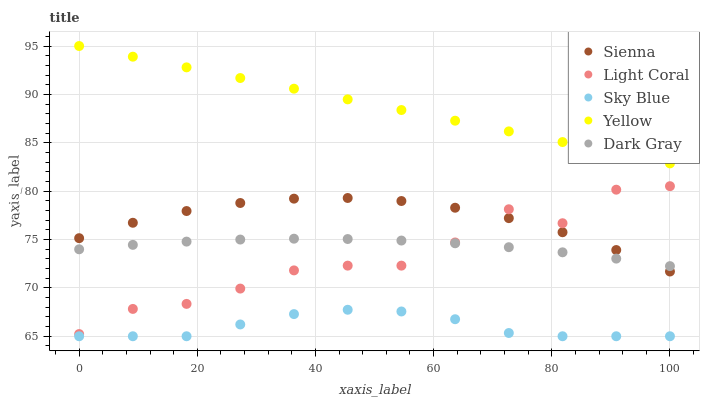Does Sky Blue have the minimum area under the curve?
Answer yes or no. Yes. Does Yellow have the maximum area under the curve?
Answer yes or no. Yes. Does Light Coral have the minimum area under the curve?
Answer yes or no. No. Does Light Coral have the maximum area under the curve?
Answer yes or no. No. Is Yellow the smoothest?
Answer yes or no. Yes. Is Light Coral the roughest?
Answer yes or no. Yes. Is Dark Gray the smoothest?
Answer yes or no. No. Is Dark Gray the roughest?
Answer yes or no. No. Does Sky Blue have the lowest value?
Answer yes or no. Yes. Does Light Coral have the lowest value?
Answer yes or no. No. Does Yellow have the highest value?
Answer yes or no. Yes. Does Light Coral have the highest value?
Answer yes or no. No. Is Dark Gray less than Yellow?
Answer yes or no. Yes. Is Light Coral greater than Sky Blue?
Answer yes or no. Yes. Does Light Coral intersect Sienna?
Answer yes or no. Yes. Is Light Coral less than Sienna?
Answer yes or no. No. Is Light Coral greater than Sienna?
Answer yes or no. No. Does Dark Gray intersect Yellow?
Answer yes or no. No. 